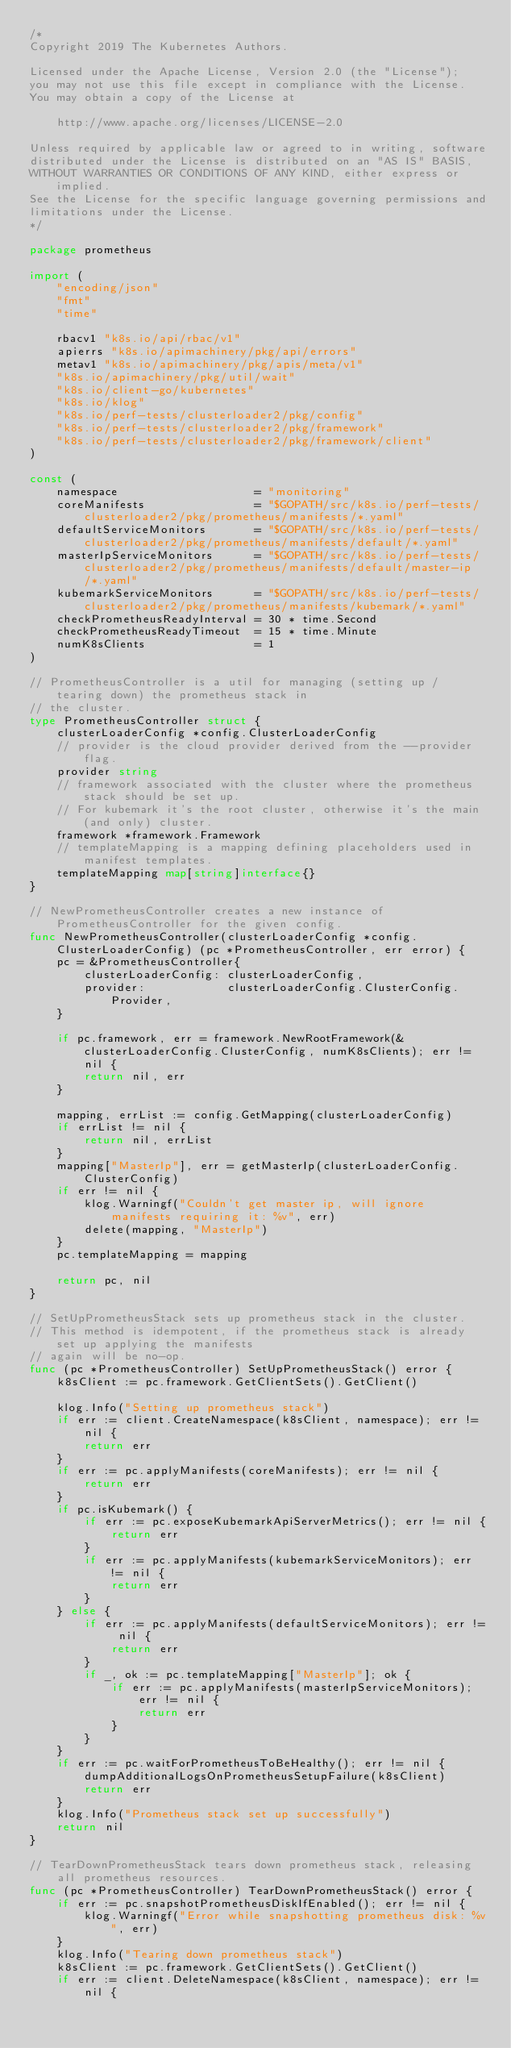Convert code to text. <code><loc_0><loc_0><loc_500><loc_500><_Go_>/*
Copyright 2019 The Kubernetes Authors.

Licensed under the Apache License, Version 2.0 (the "License");
you may not use this file except in compliance with the License.
You may obtain a copy of the License at

    http://www.apache.org/licenses/LICENSE-2.0

Unless required by applicable law or agreed to in writing, software
distributed under the License is distributed on an "AS IS" BASIS,
WITHOUT WARRANTIES OR CONDITIONS OF ANY KIND, either express or implied.
See the License for the specific language governing permissions and
limitations under the License.
*/

package prometheus

import (
	"encoding/json"
	"fmt"
	"time"

	rbacv1 "k8s.io/api/rbac/v1"
	apierrs "k8s.io/apimachinery/pkg/api/errors"
	metav1 "k8s.io/apimachinery/pkg/apis/meta/v1"
	"k8s.io/apimachinery/pkg/util/wait"
	"k8s.io/client-go/kubernetes"
	"k8s.io/klog"
	"k8s.io/perf-tests/clusterloader2/pkg/config"
	"k8s.io/perf-tests/clusterloader2/pkg/framework"
	"k8s.io/perf-tests/clusterloader2/pkg/framework/client"
)

const (
	namespace                    = "monitoring"
	coreManifests                = "$GOPATH/src/k8s.io/perf-tests/clusterloader2/pkg/prometheus/manifests/*.yaml"
	defaultServiceMonitors       = "$GOPATH/src/k8s.io/perf-tests/clusterloader2/pkg/prometheus/manifests/default/*.yaml"
	masterIpServiceMonitors      = "$GOPATH/src/k8s.io/perf-tests/clusterloader2/pkg/prometheus/manifests/default/master-ip/*.yaml"
	kubemarkServiceMonitors      = "$GOPATH/src/k8s.io/perf-tests/clusterloader2/pkg/prometheus/manifests/kubemark/*.yaml"
	checkPrometheusReadyInterval = 30 * time.Second
	checkPrometheusReadyTimeout  = 15 * time.Minute
	numK8sClients                = 1
)

// PrometheusController is a util for managing (setting up / tearing down) the prometheus stack in
// the cluster.
type PrometheusController struct {
	clusterLoaderConfig *config.ClusterLoaderConfig
	// provider is the cloud provider derived from the --provider flag.
	provider string
	// framework associated with the cluster where the prometheus stack should be set up.
	// For kubemark it's the root cluster, otherwise it's the main (and only) cluster.
	framework *framework.Framework
	// templateMapping is a mapping defining placeholders used in manifest templates.
	templateMapping map[string]interface{}
}

// NewPrometheusController creates a new instance of PrometheusController for the given config.
func NewPrometheusController(clusterLoaderConfig *config.ClusterLoaderConfig) (pc *PrometheusController, err error) {
	pc = &PrometheusController{
		clusterLoaderConfig: clusterLoaderConfig,
		provider:            clusterLoaderConfig.ClusterConfig.Provider,
	}

	if pc.framework, err = framework.NewRootFramework(&clusterLoaderConfig.ClusterConfig, numK8sClients); err != nil {
		return nil, err
	}

	mapping, errList := config.GetMapping(clusterLoaderConfig)
	if errList != nil {
		return nil, errList
	}
	mapping["MasterIp"], err = getMasterIp(clusterLoaderConfig.ClusterConfig)
	if err != nil {
		klog.Warningf("Couldn't get master ip, will ignore manifests requiring it: %v", err)
		delete(mapping, "MasterIp")
	}
	pc.templateMapping = mapping

	return pc, nil
}

// SetUpPrometheusStack sets up prometheus stack in the cluster.
// This method is idempotent, if the prometheus stack is already set up applying the manifests
// again will be no-op.
func (pc *PrometheusController) SetUpPrometheusStack() error {
	k8sClient := pc.framework.GetClientSets().GetClient()

	klog.Info("Setting up prometheus stack")
	if err := client.CreateNamespace(k8sClient, namespace); err != nil {
		return err
	}
	if err := pc.applyManifests(coreManifests); err != nil {
		return err
	}
	if pc.isKubemark() {
		if err := pc.exposeKubemarkApiServerMetrics(); err != nil {
			return err
		}
		if err := pc.applyManifests(kubemarkServiceMonitors); err != nil {
			return err
		}
	} else {
		if err := pc.applyManifests(defaultServiceMonitors); err != nil {
			return err
		}
		if _, ok := pc.templateMapping["MasterIp"]; ok {
			if err := pc.applyManifests(masterIpServiceMonitors); err != nil {
				return err
			}
		}
	}
	if err := pc.waitForPrometheusToBeHealthy(); err != nil {
		dumpAdditionalLogsOnPrometheusSetupFailure(k8sClient)
		return err
	}
	klog.Info("Prometheus stack set up successfully")
	return nil
}

// TearDownPrometheusStack tears down prometheus stack, releasing all prometheus resources.
func (pc *PrometheusController) TearDownPrometheusStack() error {
	if err := pc.snapshotPrometheusDiskIfEnabled(); err != nil {
		klog.Warningf("Error while snapshotting prometheus disk: %v", err)
	}
	klog.Info("Tearing down prometheus stack")
	k8sClient := pc.framework.GetClientSets().GetClient()
	if err := client.DeleteNamespace(k8sClient, namespace); err != nil {</code> 